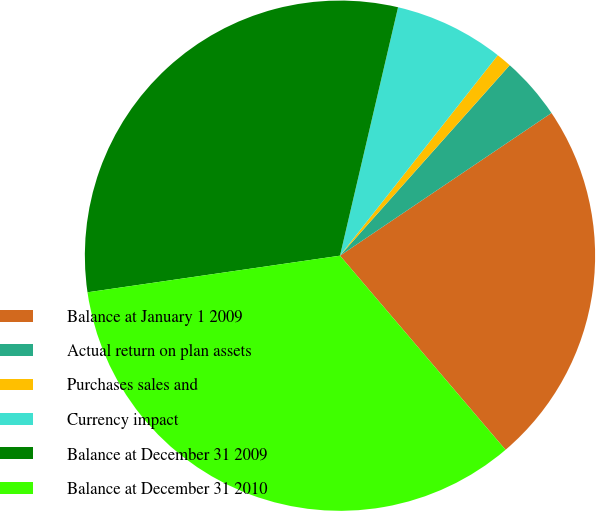<chart> <loc_0><loc_0><loc_500><loc_500><pie_chart><fcel>Balance at January 1 2009<fcel>Actual return on plan assets<fcel>Purchases sales and<fcel>Currency impact<fcel>Balance at December 31 2009<fcel>Balance at December 31 2010<nl><fcel>23.21%<fcel>3.97%<fcel>0.97%<fcel>6.96%<fcel>30.95%<fcel>33.95%<nl></chart> 